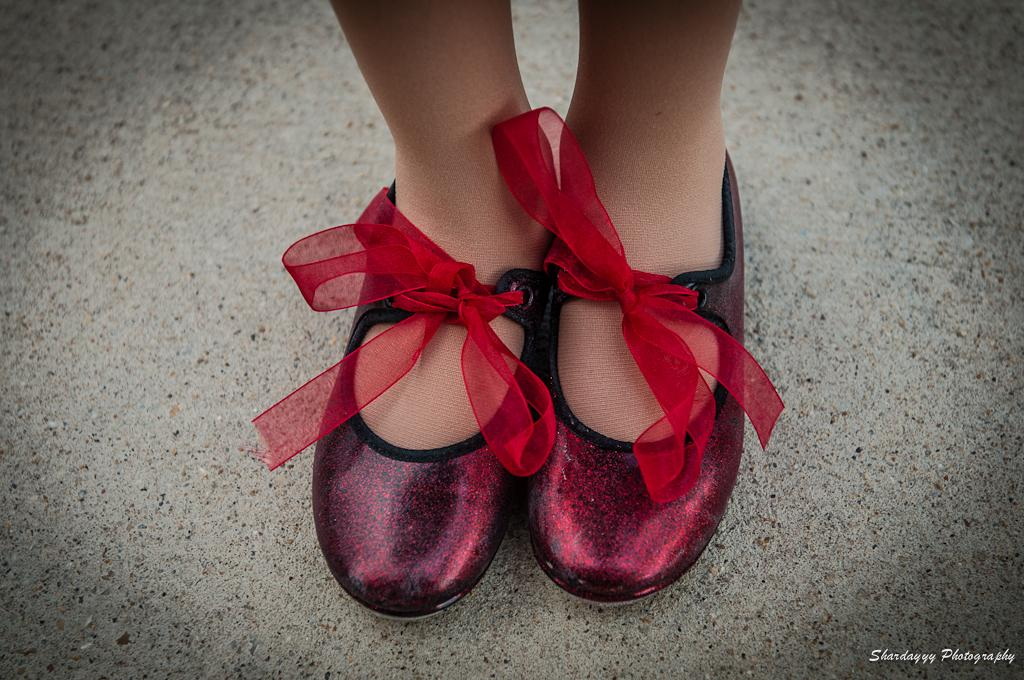Who is the main subject in the image? There is a girl in the image. What is the girl wearing on her feet? The girl is wearing shoes. What color are the shoes? The shoes are red. Are there any decorative elements on the shoes? Yes, there are red-colored ribbons on the shoes. What can be seen at the bottom of the image? There is a road visible at the bottom of the image. How many cars can be seen driving on the girl's nose in the image? There are no cars visible in the image, and the girl's nose is not mentioned or shown. 